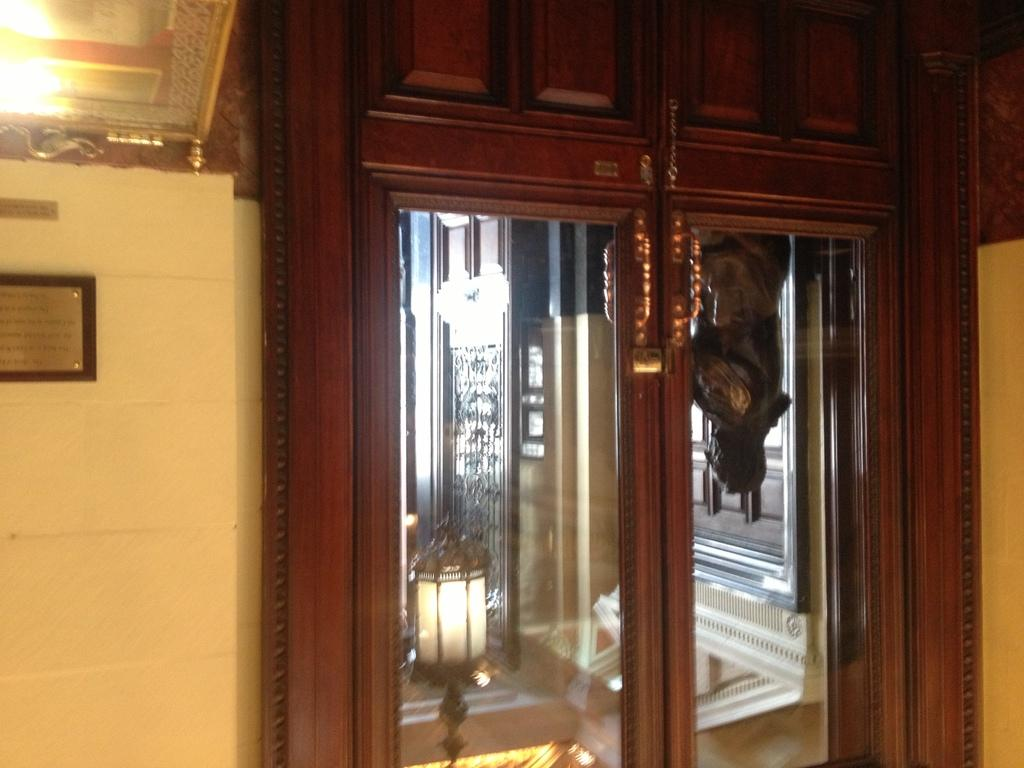Where is the image taken? The image is taken in a room. What can be seen on the left side of the image? There is a frame and a wall on the left side of the image. What is located in the center of the image? There is a closet and a mirror in the center of the image. What does the mirror reflect? The mirror reflects a lamp and a statue. What type of bells can be heard ringing in the image? There are no bells present in the image, and therefore no sound can be heard. Is there a hat visible on the statue in the mirror's reflection? The provided facts do not mention a hat on the statue, so we cannot determine its presence from the image. 